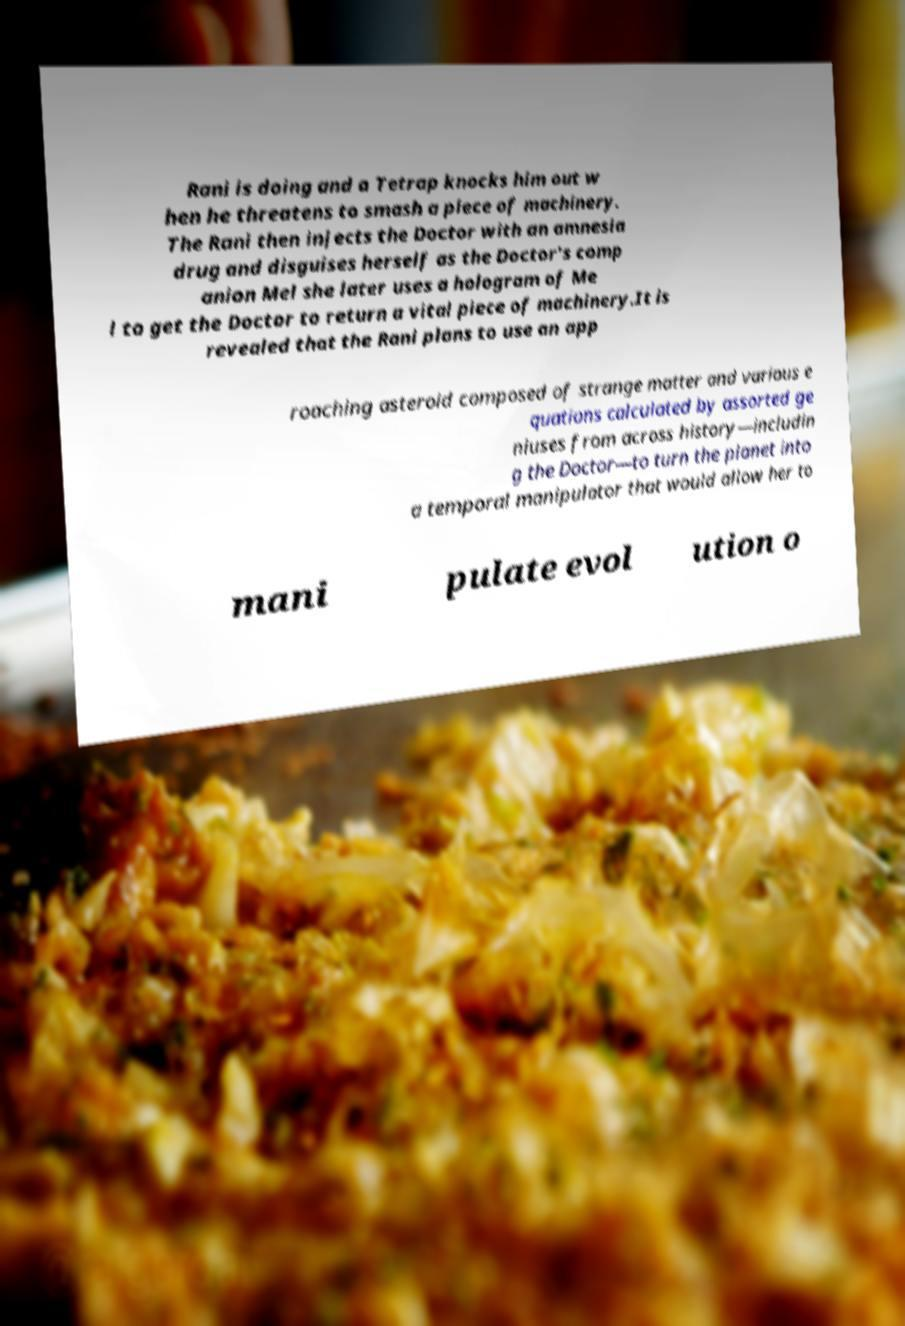Please read and relay the text visible in this image. What does it say? Rani is doing and a Tetrap knocks him out w hen he threatens to smash a piece of machinery. The Rani then injects the Doctor with an amnesia drug and disguises herself as the Doctor's comp anion Mel she later uses a hologram of Me l to get the Doctor to return a vital piece of machinery.It is revealed that the Rani plans to use an app roaching asteroid composed of strange matter and various e quations calculated by assorted ge niuses from across history—includin g the Doctor—to turn the planet into a temporal manipulator that would allow her to mani pulate evol ution o 